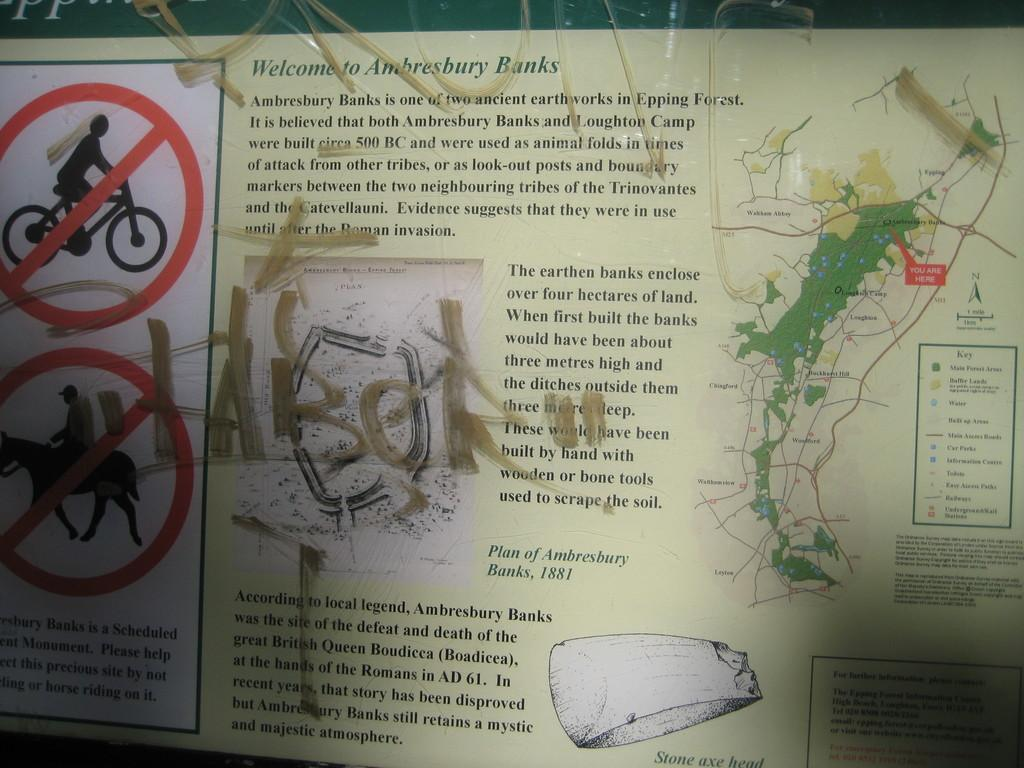Provide a one-sentence caption for the provided image. A graffitied sign welcoming visitors to Ambresbury Banks. 